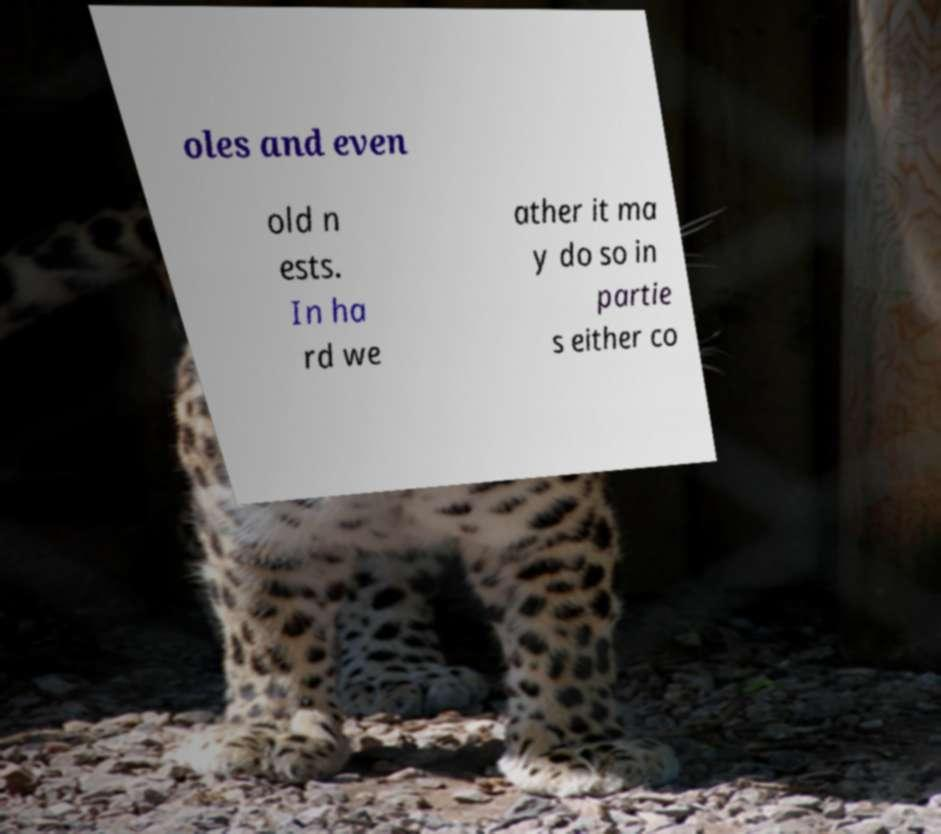Could you extract and type out the text from this image? oles and even old n ests. In ha rd we ather it ma y do so in partie s either co 